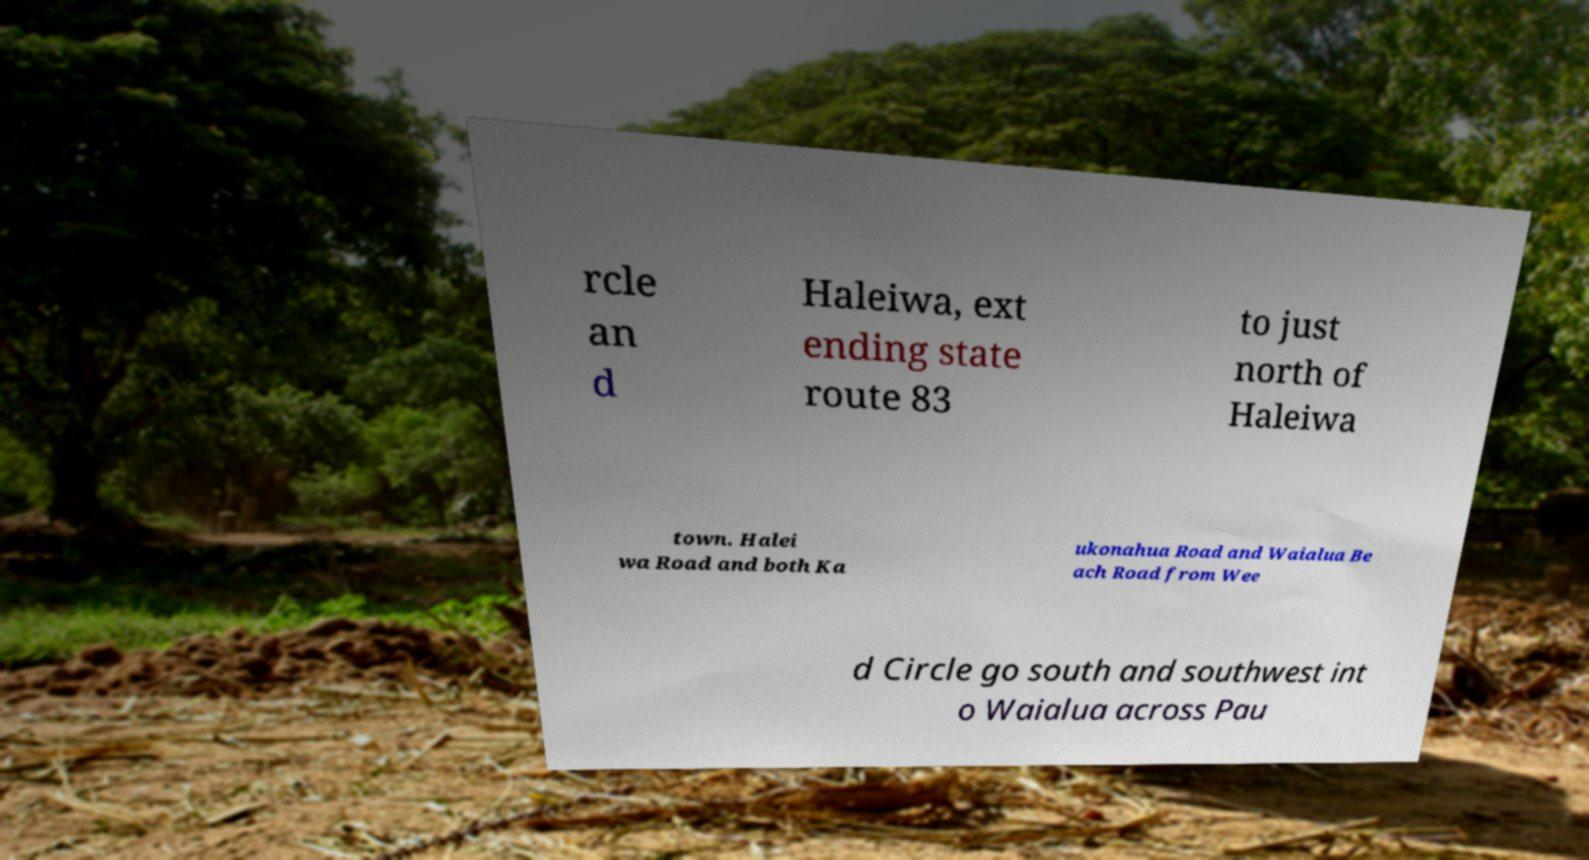Could you assist in decoding the text presented in this image and type it out clearly? rcle an d Haleiwa, ext ending state route 83 to just north of Haleiwa town. Halei wa Road and both Ka ukonahua Road and Waialua Be ach Road from Wee d Circle go south and southwest int o Waialua across Pau 